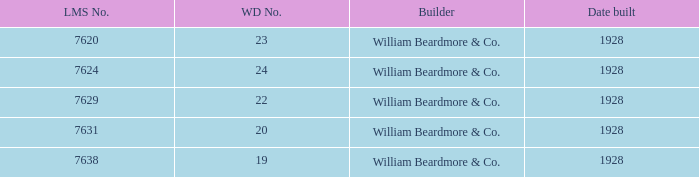Which builder corresponds to the wd number 22? William Beardmore & Co. 